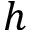Convert formula to latex. <formula><loc_0><loc_0><loc_500><loc_500>h</formula> 